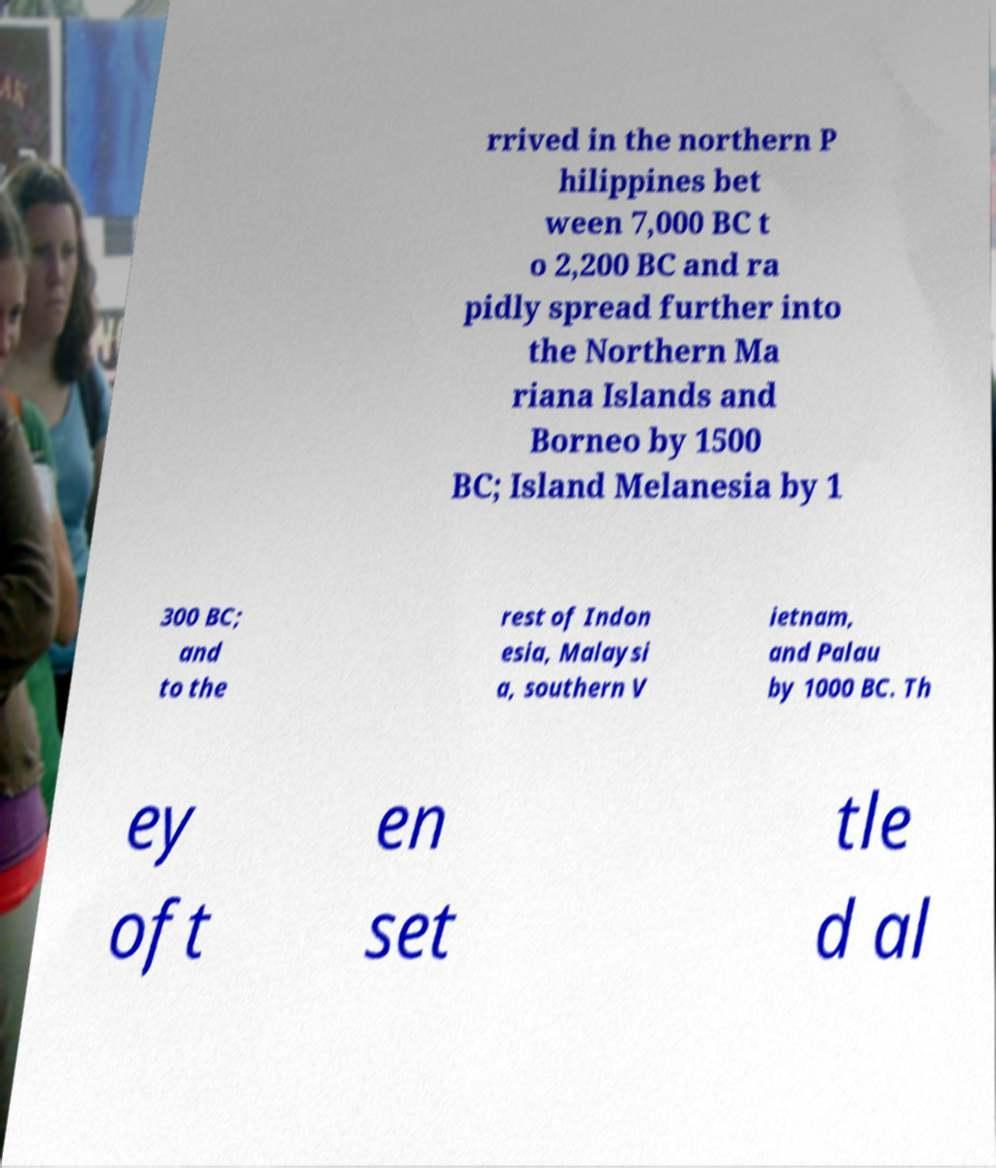Can you read and provide the text displayed in the image?This photo seems to have some interesting text. Can you extract and type it out for me? rrived in the northern P hilippines bet ween 7,000 BC t o 2,200 BC and ra pidly spread further into the Northern Ma riana Islands and Borneo by 1500 BC; Island Melanesia by 1 300 BC; and to the rest of Indon esia, Malaysi a, southern V ietnam, and Palau by 1000 BC. Th ey oft en set tle d al 